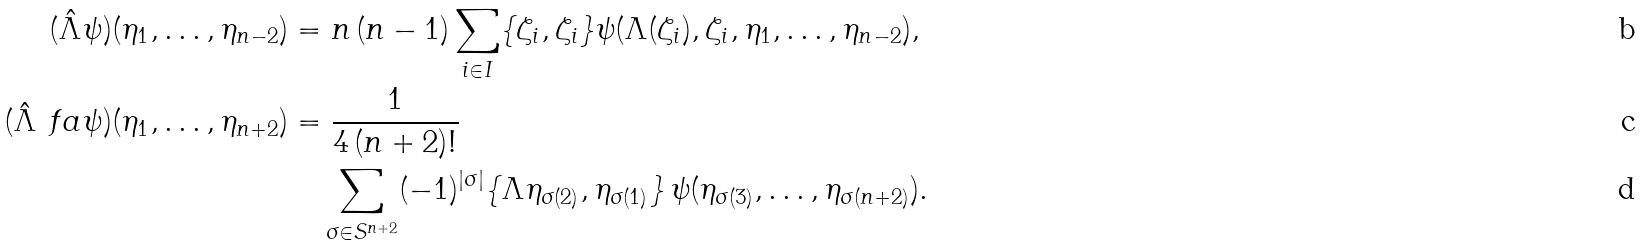<formula> <loc_0><loc_0><loc_500><loc_500>( \hat { \Lambda } \psi ) ( \eta _ { 1 } , \dots , \eta _ { n - 2 } ) & = n \, ( n - 1 ) \sum _ { i \in I } \{ \zeta _ { i } , \zeta _ { i } \} \psi ( \Lambda ( \zeta _ { i } ) , \zeta _ { i } , \eta _ { 1 } , \dots , \eta _ { n - 2 } ) , \\ ( \hat { \Lambda } ^ { \ } f a \psi ) ( \eta _ { 1 } , \dots , \eta _ { n + 2 } ) & = \frac { 1 } { 4 \, ( n + 2 ) ! } \\ & \quad \sum _ { \sigma \in S ^ { n + 2 } } ( - 1 ) ^ { | \sigma | } \{ \Lambda \eta _ { \sigma ( 2 ) } , \eta _ { \sigma ( 1 ) } \} \, \psi ( \eta _ { \sigma ( 3 ) } , \dots , \eta _ { \sigma ( n + 2 ) } ) .</formula> 